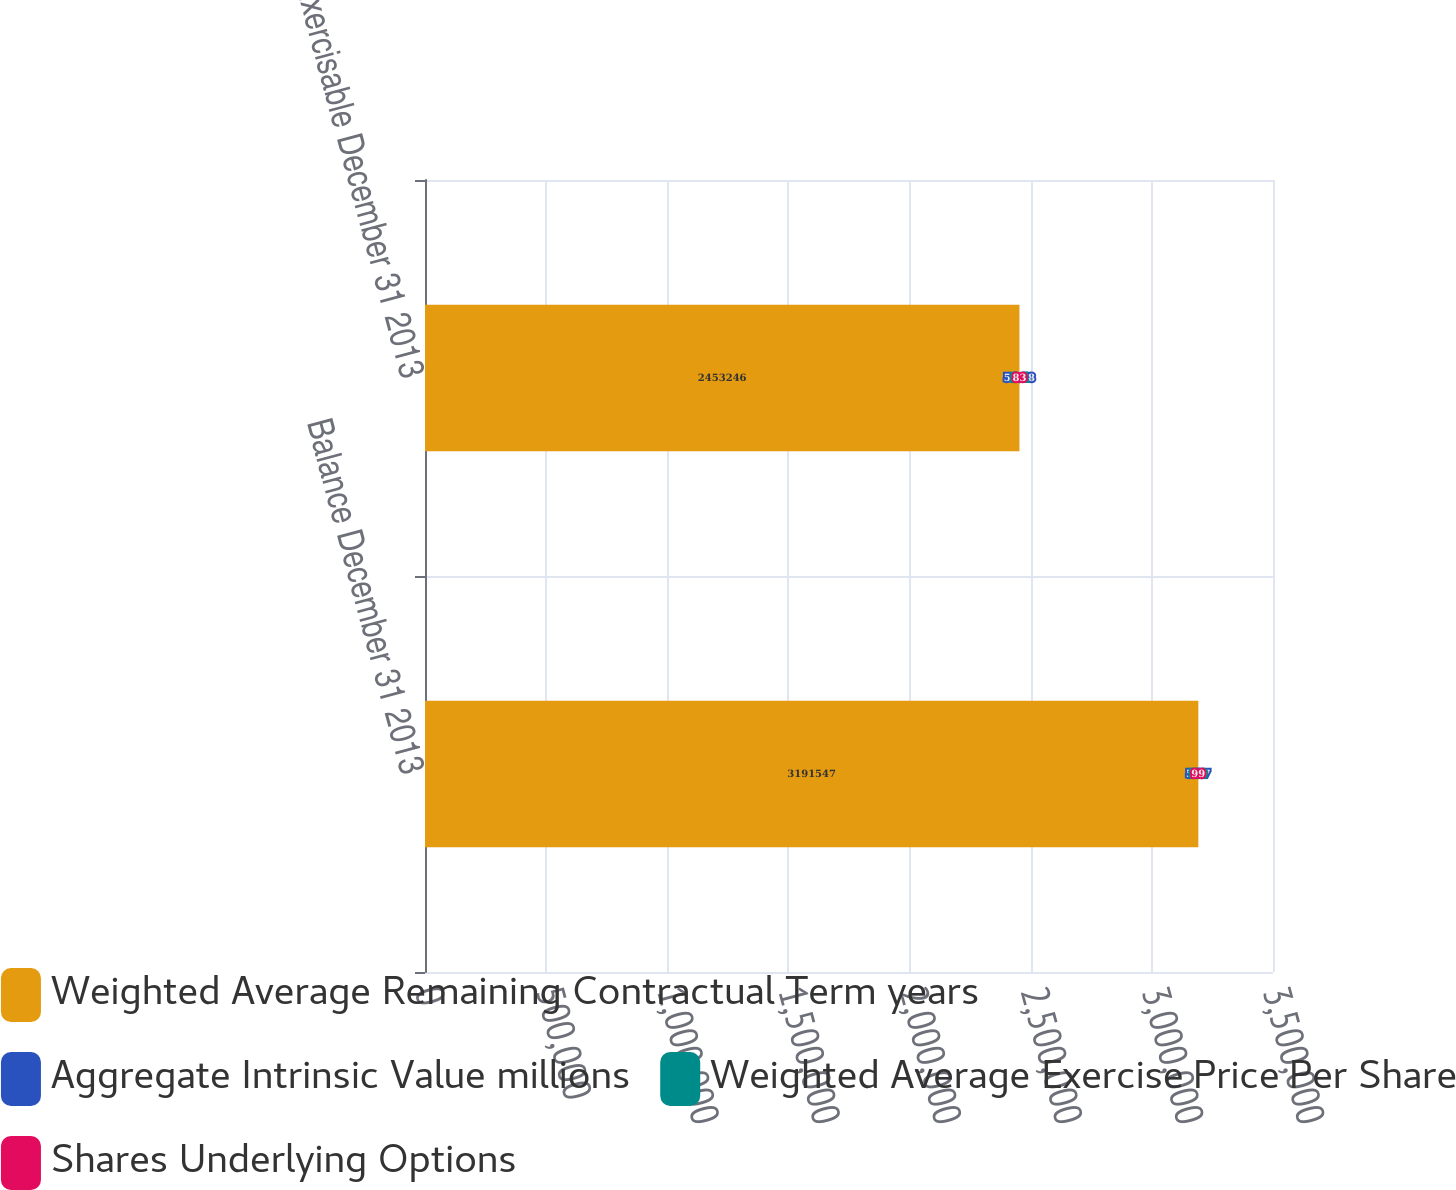Convert chart. <chart><loc_0><loc_0><loc_500><loc_500><stacked_bar_chart><ecel><fcel>Balance December 31 2013<fcel>Exercisable December 31 2013<nl><fcel>Weighted Average Remaining Contractual Term years<fcel>3.19155e+06<fcel>2.45325e+06<nl><fcel>Aggregate Intrinsic Value millions<fcel>54.7<fcel>51.78<nl><fcel>Weighted Average Exercise Price Per Share<fcel>5.9<fcel>5.1<nl><fcel>Shares Underlying Options<fcel>99<fcel>83<nl></chart> 